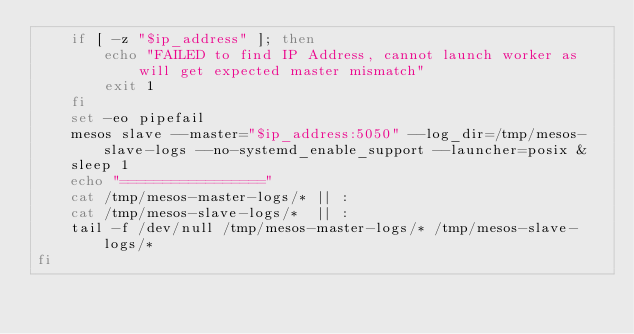<code> <loc_0><loc_0><loc_500><loc_500><_Bash_>    if [ -z "$ip_address" ]; then
        echo "FAILED to find IP Address, cannot launch worker as will get expected master mismatch"
        exit 1
    fi
    set -eo pipefail
    mesos slave --master="$ip_address:5050" --log_dir=/tmp/mesos-slave-logs --no-systemd_enable_support --launcher=posix &
    sleep 1
    echo "================="
    cat /tmp/mesos-master-logs/* || :
    cat /tmp/mesos-slave-logs/*  || :
    tail -f /dev/null /tmp/mesos-master-logs/* /tmp/mesos-slave-logs/*
fi
</code> 